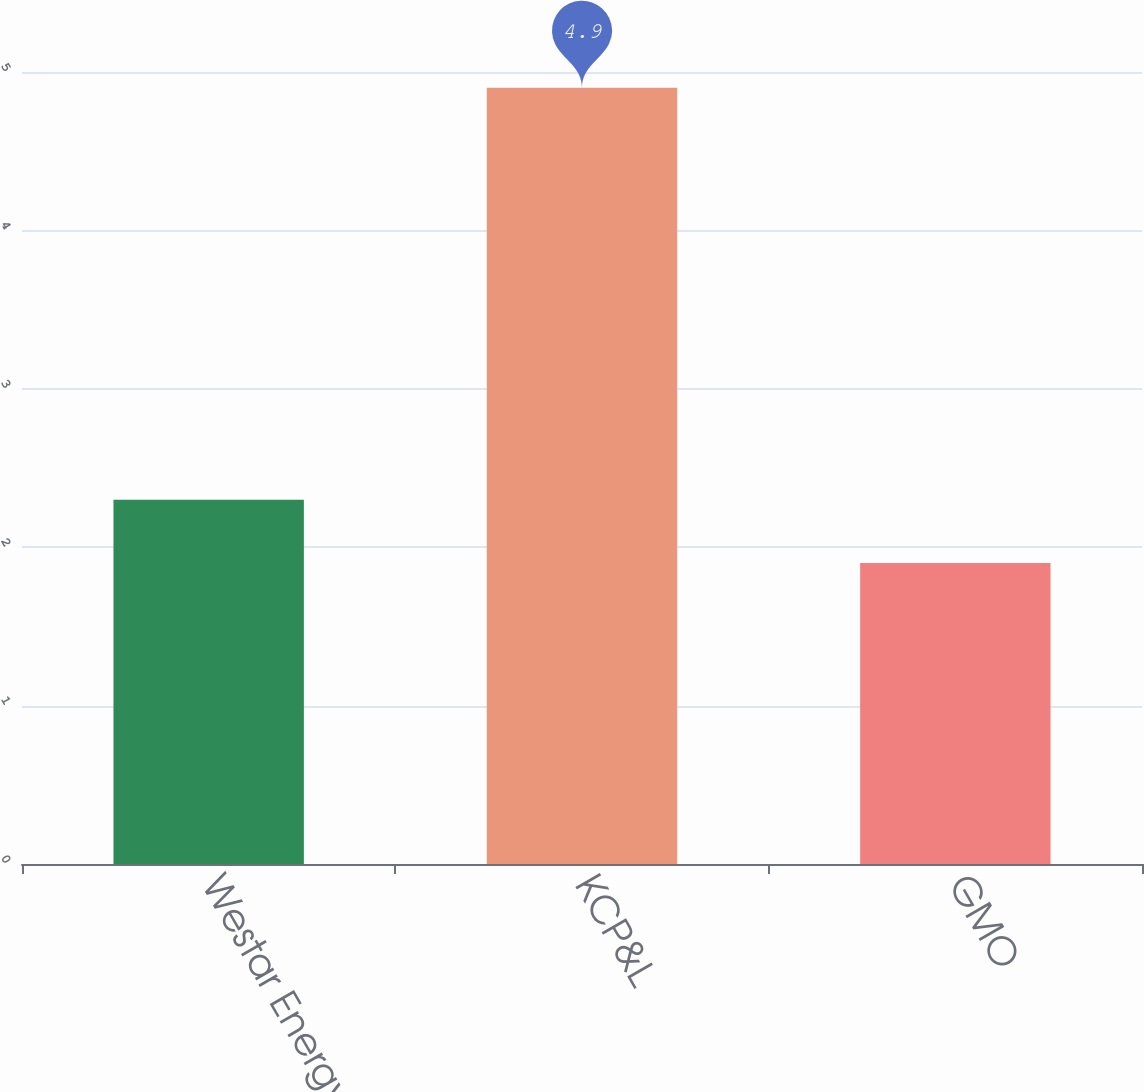Convert chart to OTSL. <chart><loc_0><loc_0><loc_500><loc_500><bar_chart><fcel>Westar Energy<fcel>KCP&L<fcel>GMO<nl><fcel>2.3<fcel>4.9<fcel>1.9<nl></chart> 